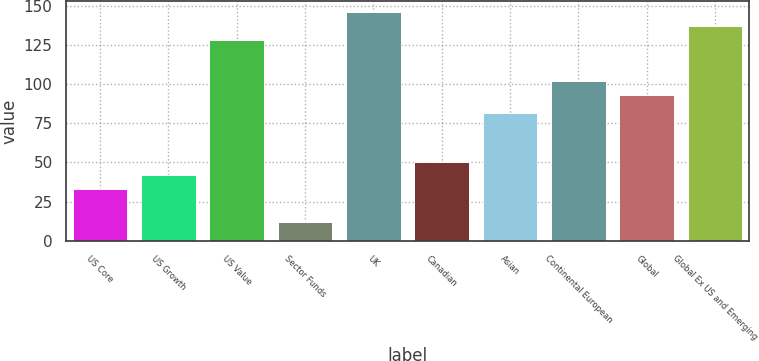Convert chart to OTSL. <chart><loc_0><loc_0><loc_500><loc_500><bar_chart><fcel>US Core<fcel>US Growth<fcel>US Value<fcel>Sector Funds<fcel>UK<fcel>Canadian<fcel>Asian<fcel>Continental European<fcel>Global<fcel>Global Ex US and Emerging<nl><fcel>33<fcel>41.8<fcel>128.2<fcel>12<fcel>145.8<fcel>50.6<fcel>81.6<fcel>101.8<fcel>93<fcel>137<nl></chart> 